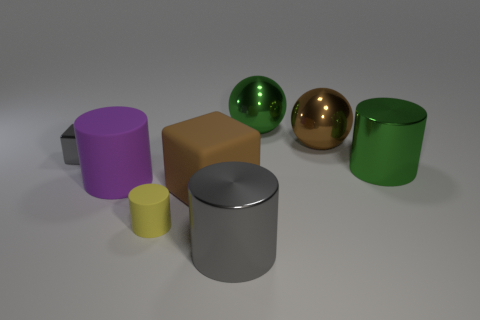What is the material of the other brown thing that is the same size as the brown metal thing?
Your answer should be compact. Rubber. How many other things are there of the same material as the large gray object?
Your answer should be compact. 4. What color is the metallic object that is both behind the small block and in front of the green ball?
Give a very brief answer. Brown. What number of objects are either green shiny balls on the right side of the metal block or large shiny cylinders?
Ensure brevity in your answer.  3. How many other objects are the same color as the large block?
Your answer should be very brief. 1. Are there an equal number of green things that are in front of the yellow matte object and big cyan matte cylinders?
Provide a succinct answer. Yes. What number of tiny gray shiny objects are right of the big metallic cylinder on the left side of the large brown object behind the purple rubber cylinder?
Provide a succinct answer. 0. Is there anything else that has the same size as the brown rubber block?
Give a very brief answer. Yes. Do the green sphere and the brown object that is behind the metal cube have the same size?
Make the answer very short. Yes. What number of tiny shiny things are there?
Give a very brief answer. 1. 